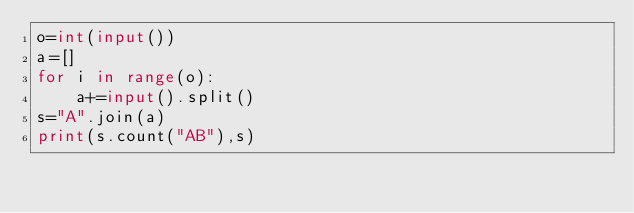<code> <loc_0><loc_0><loc_500><loc_500><_Python_>o=int(input())
a=[]
for i in range(o):
    a+=input().split()
s="A".join(a)
print(s.count("AB"),s)</code> 